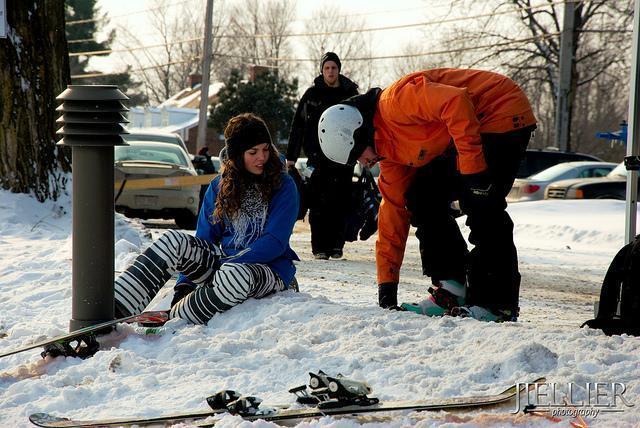How many people are there?
Give a very brief answer. 3. 